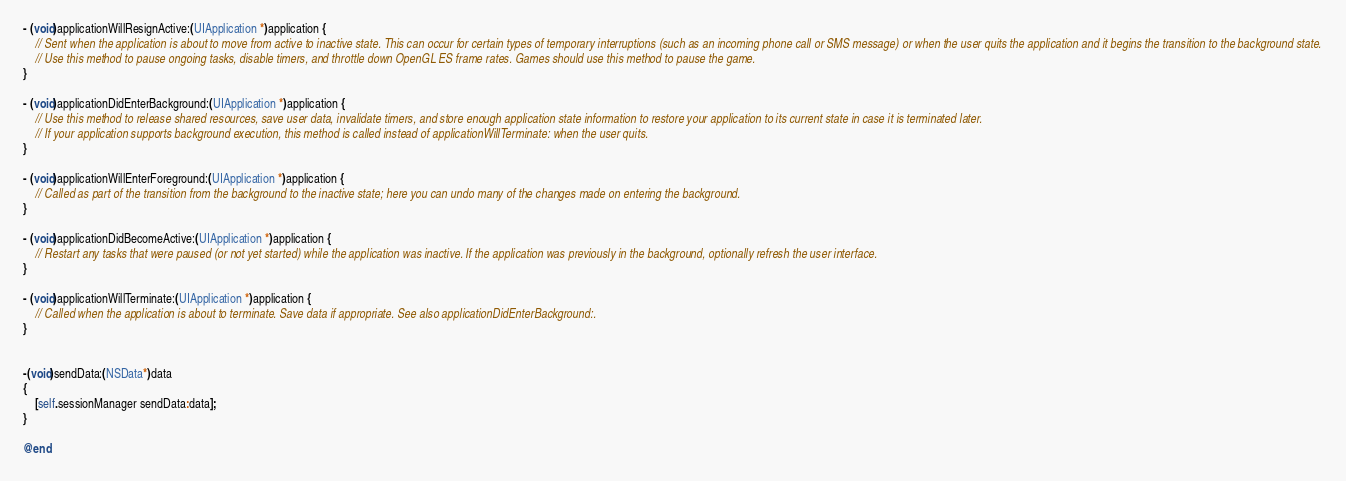Convert code to text. <code><loc_0><loc_0><loc_500><loc_500><_ObjectiveC_>- (void)applicationWillResignActive:(UIApplication *)application {
    // Sent when the application is about to move from active to inactive state. This can occur for certain types of temporary interruptions (such as an incoming phone call or SMS message) or when the user quits the application and it begins the transition to the background state.
    // Use this method to pause ongoing tasks, disable timers, and throttle down OpenGL ES frame rates. Games should use this method to pause the game.
}

- (void)applicationDidEnterBackground:(UIApplication *)application {
    // Use this method to release shared resources, save user data, invalidate timers, and store enough application state information to restore your application to its current state in case it is terminated later.
    // If your application supports background execution, this method is called instead of applicationWillTerminate: when the user quits.
}

- (void)applicationWillEnterForeground:(UIApplication *)application {
    // Called as part of the transition from the background to the inactive state; here you can undo many of the changes made on entering the background.
}

- (void)applicationDidBecomeActive:(UIApplication *)application {
    // Restart any tasks that were paused (or not yet started) while the application was inactive. If the application was previously in the background, optionally refresh the user interface.
}

- (void)applicationWillTerminate:(UIApplication *)application {
    // Called when the application is about to terminate. Save data if appropriate. See also applicationDidEnterBackground:.
}


-(void)sendData:(NSData*)data
{
    [self.sessionManager sendData:data];
}

@end
</code> 